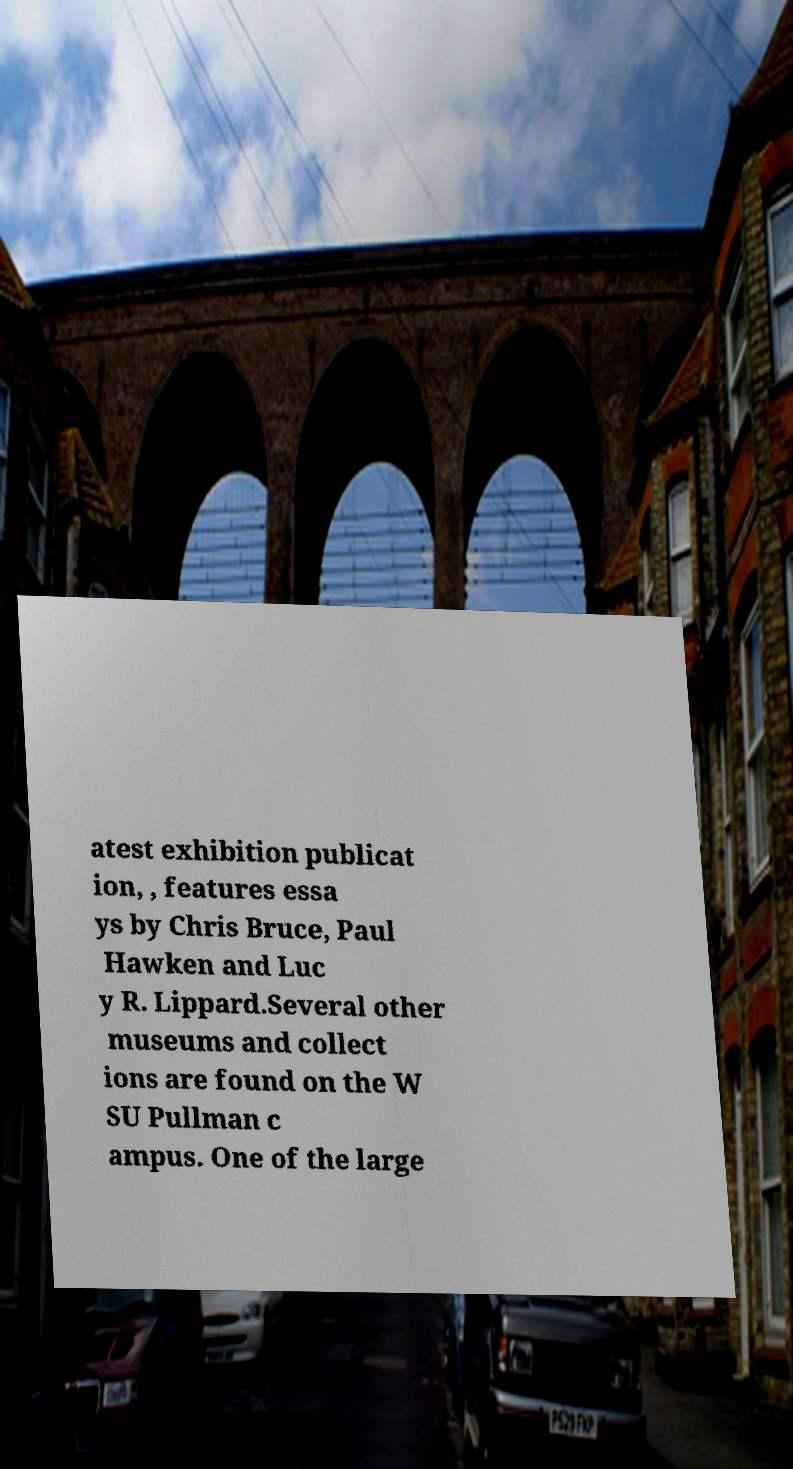Can you read and provide the text displayed in the image?This photo seems to have some interesting text. Can you extract and type it out for me? atest exhibition publicat ion, , features essa ys by Chris Bruce, Paul Hawken and Luc y R. Lippard.Several other museums and collect ions are found on the W SU Pullman c ampus. One of the large 